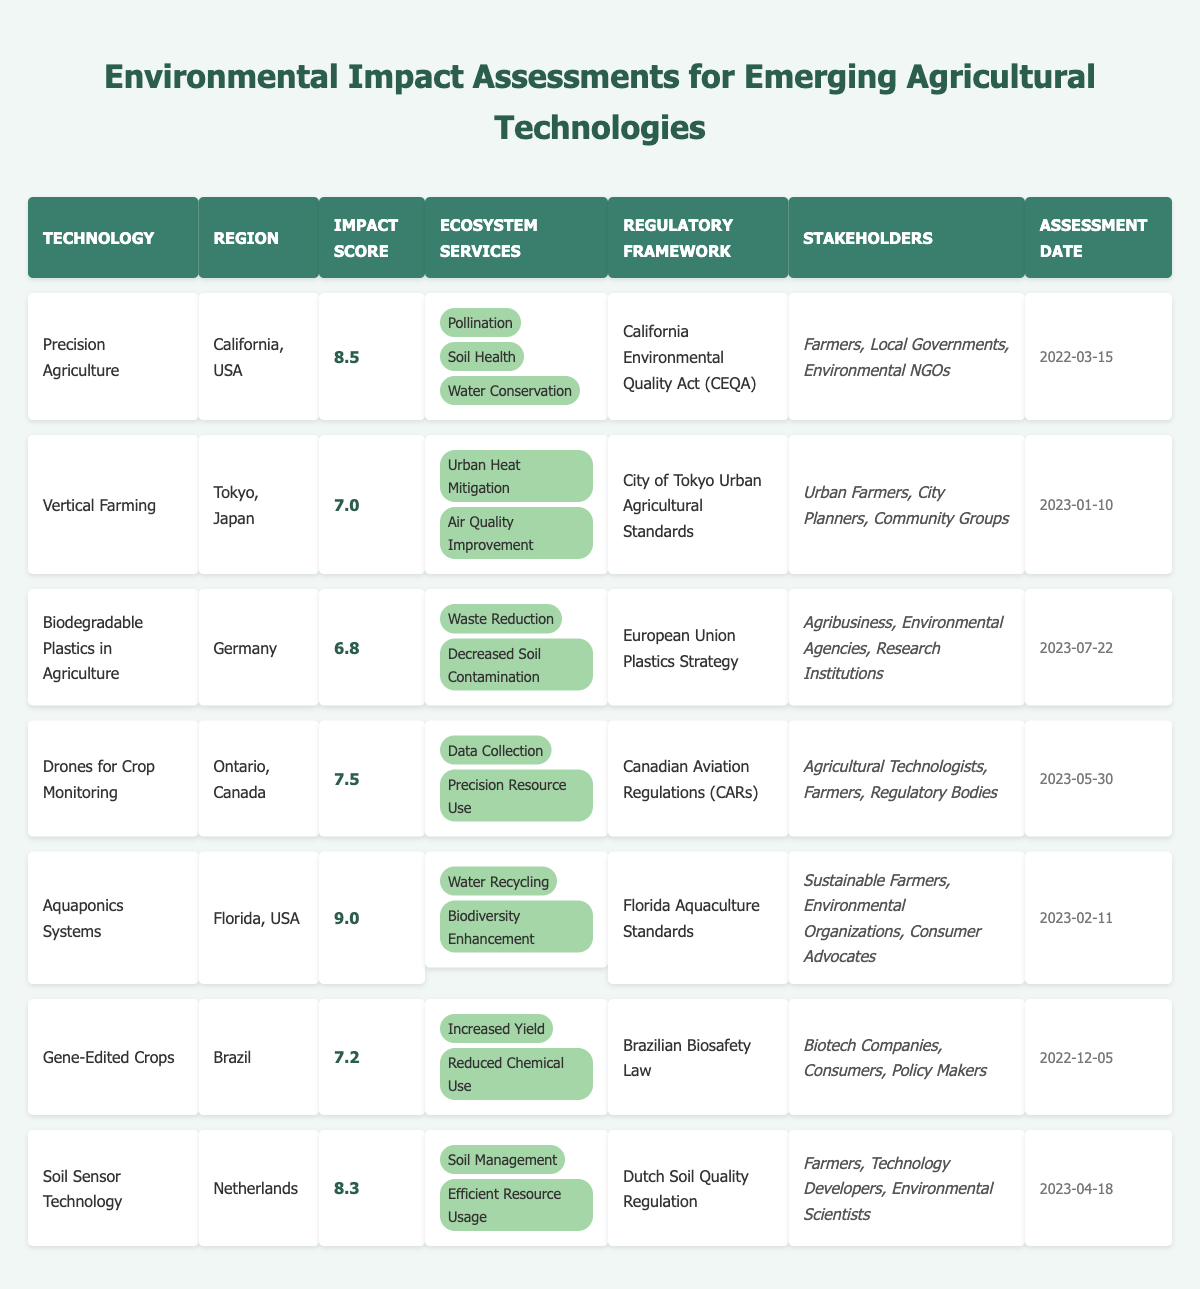What is the highest impact score among the technologies? The technologies in the table are listed with their impact scores. The highest impact score is associated with "Aquaponics Systems," which has a score of 9.0.
Answer: 9.0 Which technology focuses on "Waste Reduction" as an ecosystem service? From the table, "Biodegradable Plastics in Agriculture" is the only technology that lists "Waste Reduction" as one of its ecosystem services.
Answer: Biodegradable Plastics in Agriculture How many technologies have an impact score greater than 8.0? The technologies with impact scores are: 8.5 (Precision Agriculture), 9.0 (Aquaponics Systems), and 8.3 (Soil Sensor Technology). This totals to three technologies with scores above 8.0.
Answer: 3 What is the regulatory framework for "Drones for Crop Monitoring"? The table states that "Drones for Crop Monitoring" falls under the "Canadian Aviation Regulations (CARs)" for its regulatory framework.
Answer: Canadian Aviation Regulations (CARs) Does "Gene-Edited Crops" have a higher impact score than "Vertical Farming"? "Gene-Edited Crops" has an impact score of 7.2, while "Vertical Farming" has a score of 7.0. Since 7.2 is greater than 7.0, the statement is true.
Answer: Yes What are the ecosystem services provided by "Aquaponics Systems"? The ecosystem services for "Aquaponics Systems" listed in the table are "Water Recycling" and "Biodiversity Enhancement."
Answer: Water Recycling, Biodiversity Enhancement Which region does the technology with the second lowest impact score come from? The technology with the second lowest score is "Biodegradable Plastics in Agriculture" with an impact score of 6.8, and it is from Germany.
Answer: Germany Which technology was assessed most recently and what’s its impact score? The most recent assessment date in the table is "2023-07-22" for "Biodegradable Plastics in Agriculture," which has an impact score of 6.8.
Answer: Biodegradable Plastics in Agriculture, 6.8 Can we say that all stakeholders listed for "Aquaponics Systems" include Environmental Organizations? Reviewing the stakeholders for "Aquaponics Systems," they include "Sustainable Farmers," "Environmental Organizations," and "Consumer Advocates." Therefore, the statement is true.
Answer: Yes What is the average impact score of the technologies listed in the table? The impact scores are 8.5, 7.0, 6.8, 7.5, 9.0, 7.2, and 8.3. Calculating the average: (8.5 + 7.0 + 6.8 + 7.5 + 9.0 + 7.2 + 8.3) / 7 = 7.7857, which rounds to approximately 7.79.
Answer: 7.79 